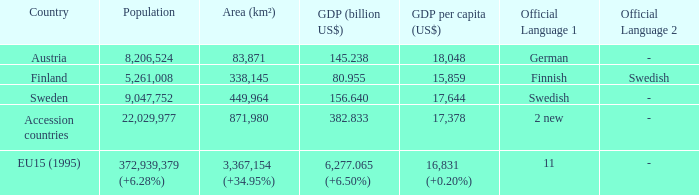Name the population for 11 languages 372,939,379 (+6.28%). Would you mind parsing the complete table? {'header': ['Country', 'Population', 'Area (km²)', 'GDP (billion US$)', 'GDP per capita (US$)', 'Official Language 1', 'Official Language 2'], 'rows': [['Austria', '8,206,524', '83,871', '145.238', '18,048', 'German', '-'], ['Finland', '5,261,008', '338,145', '80.955', '15,859', 'Finnish', 'Swedish'], ['Sweden', '9,047,752', '449,964', '156.640', '17,644', 'Swedish', '-'], ['Accession countries', '22,029,977', '871,980', '382.833', '17,378', '2 new', '-'], ['EU15 (1995)', '372,939,379 (+6.28%)', '3,367,154 (+34.95%)', '6,277.065 (+6.50%)', '16,831 (+0.20%)', '11', '-']]} 